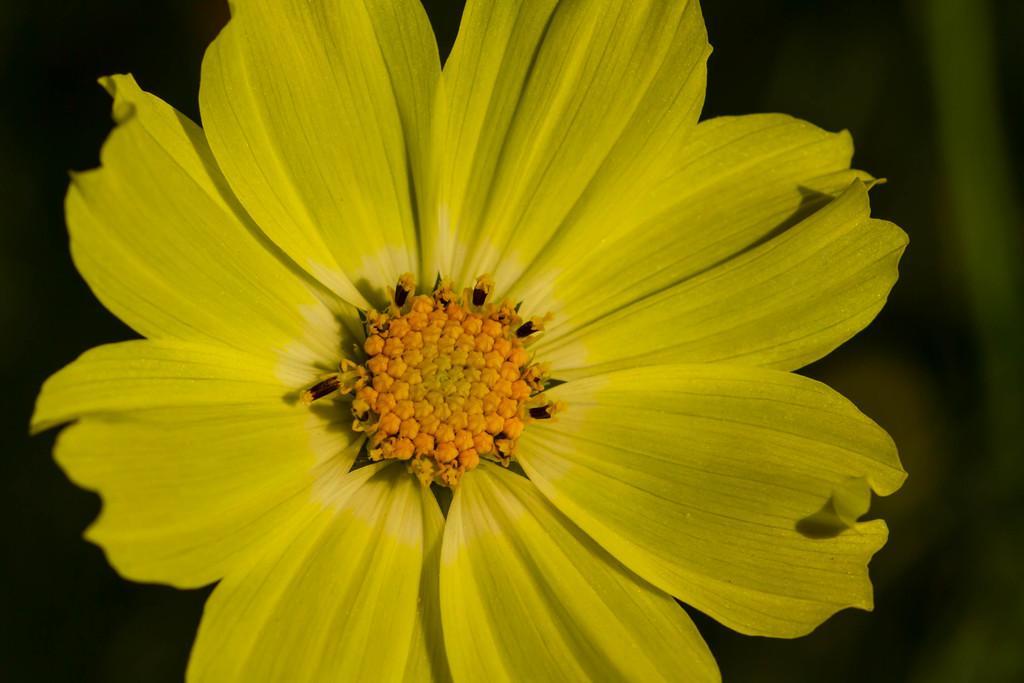How would you summarize this image in a sentence or two? In this picture we can see a flower and there is a blur background. 